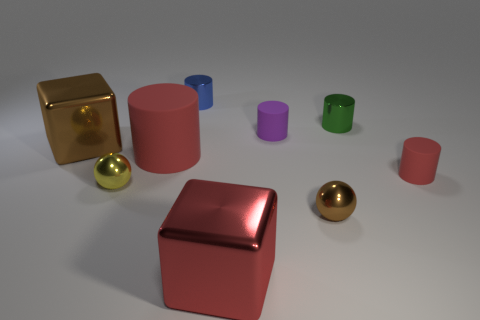Are there any balls of the same size as the green cylinder?
Provide a short and direct response. Yes. What is the size of the block that is in front of the brown metallic cube?
Keep it short and to the point. Large. What size is the purple cylinder?
Offer a terse response. Small. How many blocks are small green metal objects or red things?
Your response must be concise. 1. What size is the brown sphere that is the same material as the big red cube?
Make the answer very short. Small. What number of small rubber cylinders have the same color as the large rubber cylinder?
Provide a short and direct response. 1. There is a blue metallic thing; are there any big rubber cylinders behind it?
Offer a terse response. No. There is a tiny red thing; is it the same shape as the red rubber thing that is behind the small red cylinder?
Make the answer very short. Yes. How many objects are rubber cylinders behind the small red thing or tiny yellow metallic balls?
Your answer should be very brief. 3. How many metallic objects are on the right side of the purple matte object and in front of the tiny yellow thing?
Offer a very short reply. 1. 